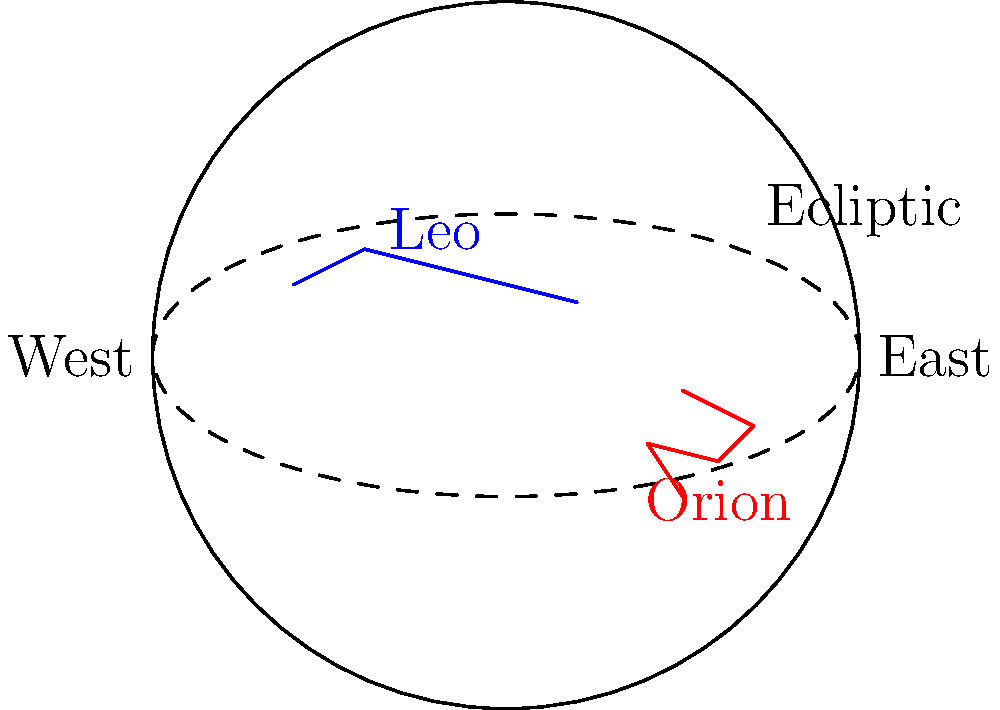As a podcast producer exploring astronomy content, you've learned about the apparent motion of constellations. Why does Leo appear higher in the night sky during spring, while Orion is more prominent in winter evenings? To understand this phenomenon, let's break it down step-by-step:

1. Earth's orbit: The Earth revolves around the Sun in an elliptical orbit, completing one revolution in a year.

2. Earth's axis tilt: The Earth's axis is tilted at an angle of approximately 23.5° relative to its orbital plane.

3. Celestial sphere: Astronomers use the concept of a celestial sphere to map the positions of stars and constellations as seen from Earth.

4. Ecliptic: The apparent path of the Sun across the celestial sphere is called the ecliptic. It's represented by the dashed line in the diagram.

5. Seasonal changes: As Earth orbits the Sun, different constellations appear higher or lower in the night sky depending on the season.

6. Leo's position: Leo is located near the ecliptic in the region of the sky that's highest during spring nights in the Northern Hemisphere.

7. Orion's position: Orion is located south of the ecliptic and is most visible during winter nights in the Northern Hemisphere.

8. Earth's nighttime view: During spring, Earth's nighttime side faces the part of the sky where Leo is located, making it appear higher.

9. Winter vs. Spring: In winter, Earth's nighttime side faces the region where Orion is prominent, while in spring, this area is mostly visible during daylight hours.

The apparent motion of these constellations throughout the year is due to Earth's orbital motion and axial tilt, causing different parts of the celestial sphere to be visible during night hours in different seasons.
Answer: Earth's orbit and axial tilt cause seasonal changes in visible constellations. 